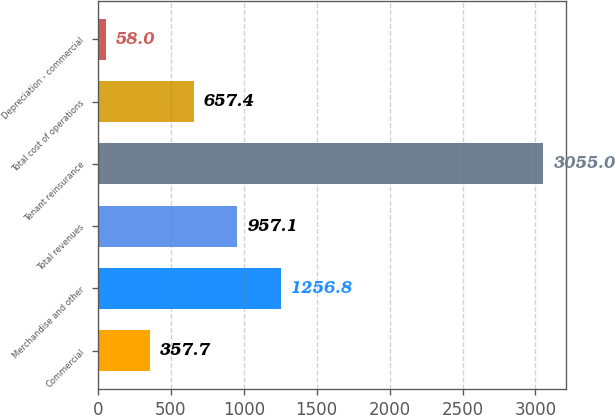Convert chart. <chart><loc_0><loc_0><loc_500><loc_500><bar_chart><fcel>Commercial<fcel>Merchandise and other<fcel>Total revenues<fcel>Tenant reinsurance<fcel>Total cost of operations<fcel>Depreciation - commercial<nl><fcel>357.7<fcel>1256.8<fcel>957.1<fcel>3055<fcel>657.4<fcel>58<nl></chart> 